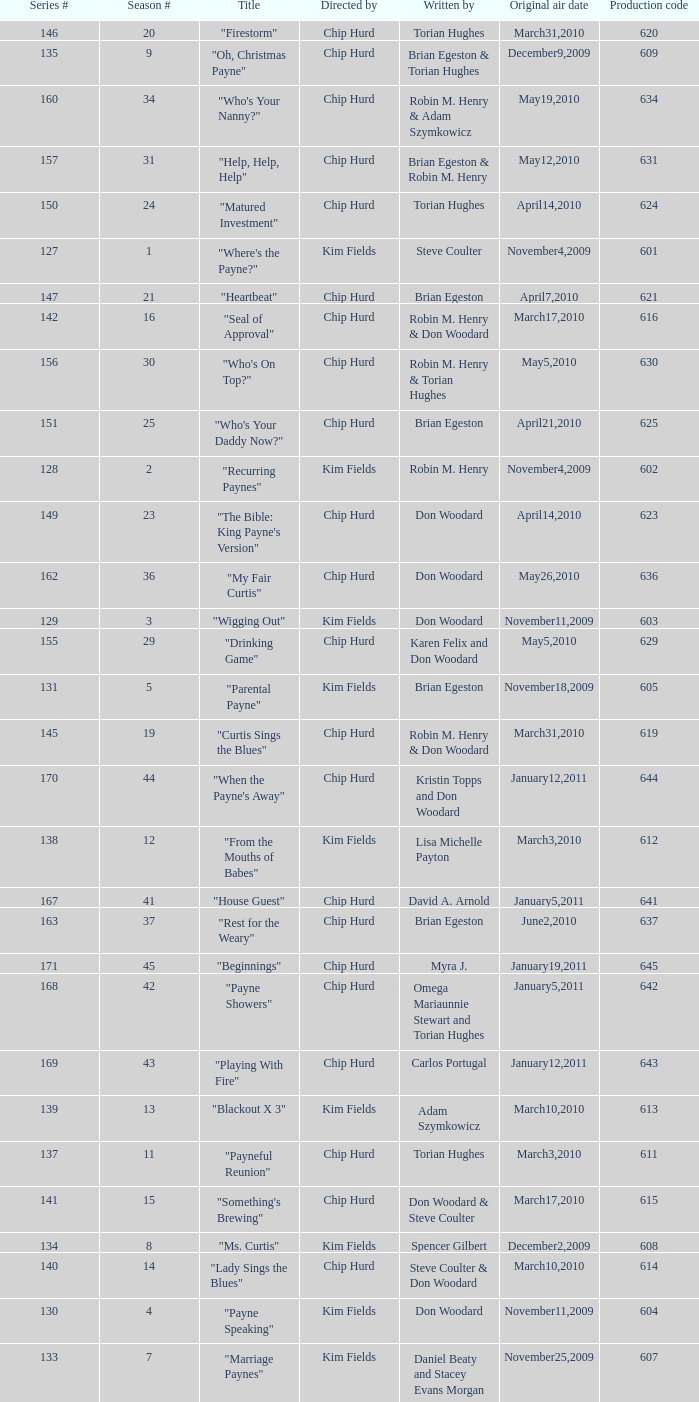What is the original air dates for the title "firestorm"? March31,2010. 